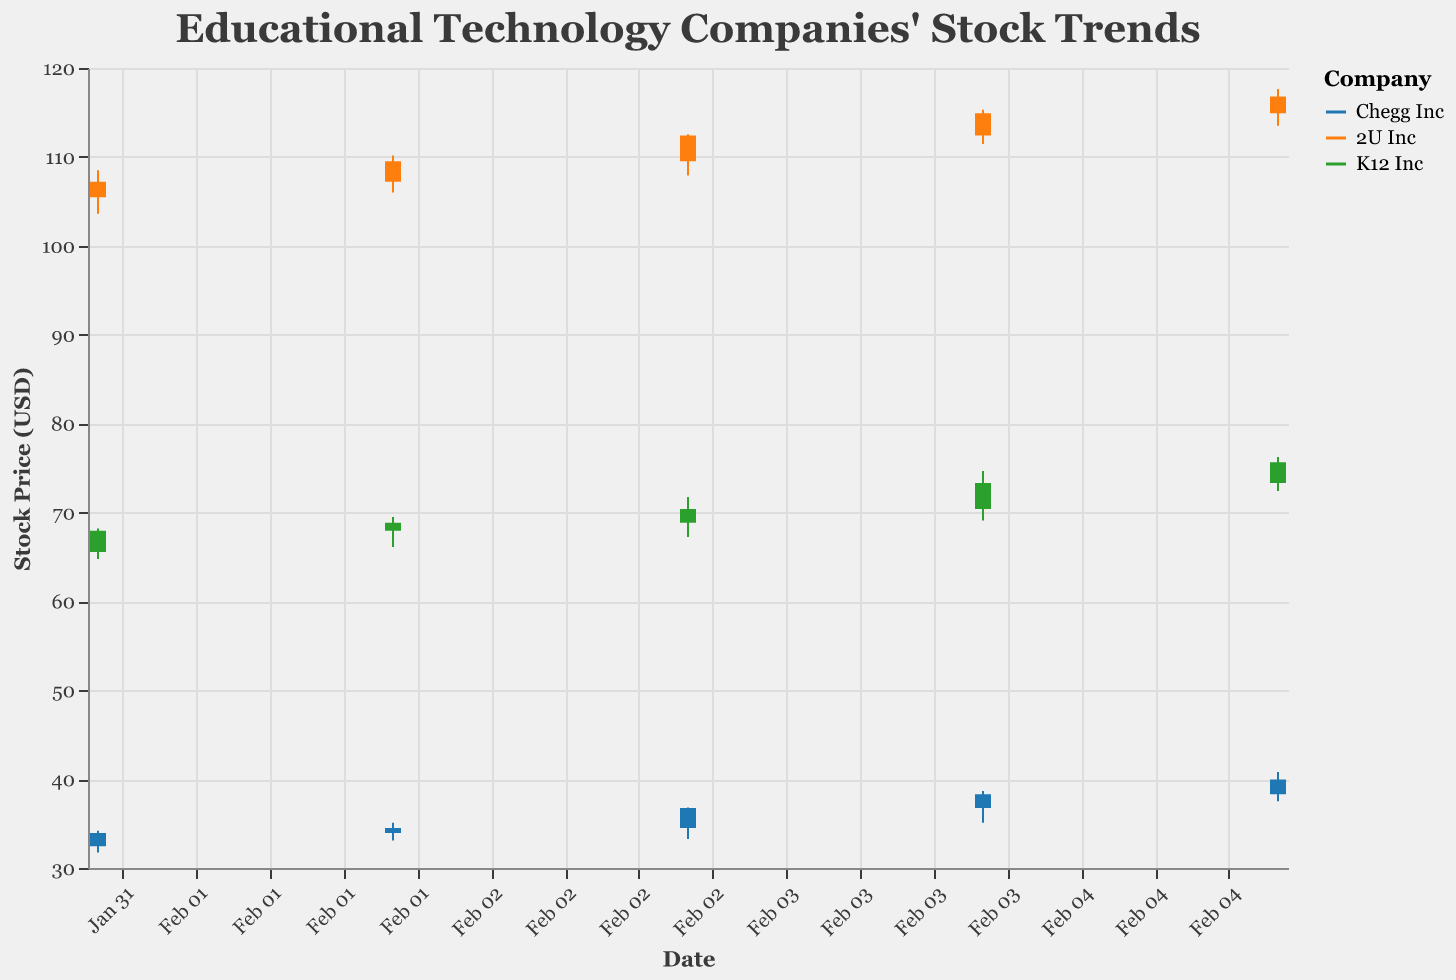What is the title of the figure? The title of the figure is displayed at the top and is "Educational Technology Companies' Stock Trends." This information is clear from the title's placement and styling.
Answer: Educational Technology Companies' Stock Trends Which company had the highest closing price on February 3, 2020? To determine this, identify the closing prices of the three companies on February 3, 2020. Chegg Inc had a closing price of 36.75, 2U Inc had a closing price of 112.40, and K12 Inc had a closing price of 70.40. Among these, 2U Inc had the highest closing price.
Answer: 2U Inc How did Chegg Inc's stock price change from February 1 to February 5, 2020? Calculate the difference between the closing prices on February 5 and February 1 for Chegg Inc. The closing price on February 1 was 33.95 and on February 5 was 39.95. So, 39.95 - 33.95 = 6.00.
Answer: Increased by 6.00 Which company had the greatest increase in closing stock price from February 1 to February 5, 2020? Calculate the difference in closing prices from February 1 to February 5 for each company: 
- Chegg Inc: 39.95 - 33.95 = 6.00
- 2U Inc: 116.80 - 107.20 = 9.60
- K12 Inc: 75.65 - 67.95 = 7.70
2U Inc had the greatest increase of 9.60.
Answer: 2U Inc What is the trend of K12 Inc's stock price over the given dates? To find the trend, observe the closing prices of K12 Inc from February 1 to February 5. The closing prices are 67.95, 68.85, 70.40, 73.30, and 75.65 respectively. The stock price shows an increasing trend over these dates.
Answer: Increasing On which date did Chegg Inc have the largest daily range between its high and low prices? Calculate the daily range (High - Low) for each date for Chegg Inc:
- Feb 1: 34.20 - 31.75 = 2.45
- Feb 2: 35.10 - 33.10 = 2.00
- Feb 3: 36.80 - 33.25 = 3.55
- Feb 4: 38.65 - 35.10 = 3.55
- Feb 5: 40.80 - 37.50 = 3.30
The largest range occurred on February 3 and February 4, both with a range of 3.55.
Answer: February 3 and February 4 